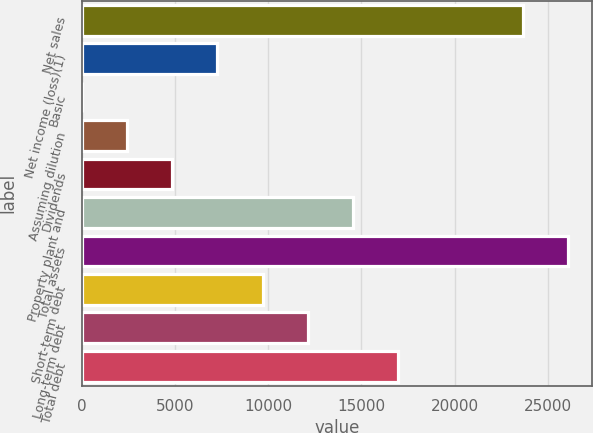Convert chart to OTSL. <chart><loc_0><loc_0><loc_500><loc_500><bar_chart><fcel>Net sales<fcel>Net income (loss)(1)<fcel>Basic<fcel>Assuming dilution<fcel>Dividends<fcel>Property plant and<fcel>Total assets<fcel>Short-term debt<fcel>Long-term debt<fcel>Total debt<nl><fcel>23652<fcel>7267.89<fcel>0.12<fcel>2422.71<fcel>4845.3<fcel>14535.7<fcel>26074.6<fcel>9690.48<fcel>12113.1<fcel>16958.2<nl></chart> 